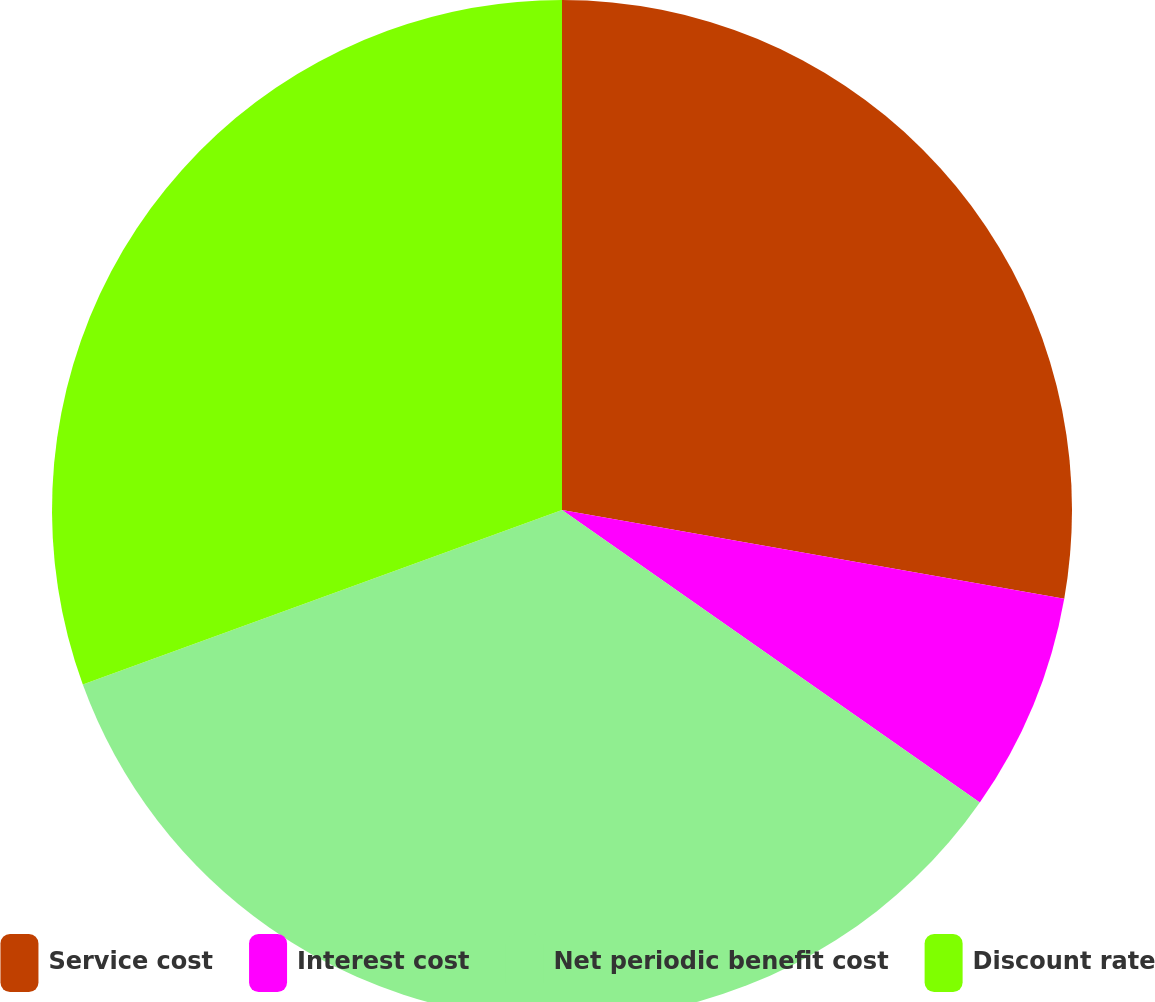<chart> <loc_0><loc_0><loc_500><loc_500><pie_chart><fcel>Service cost<fcel>Interest cost<fcel>Net periodic benefit cost<fcel>Discount rate<nl><fcel>27.78%<fcel>6.94%<fcel>34.72%<fcel>30.56%<nl></chart> 